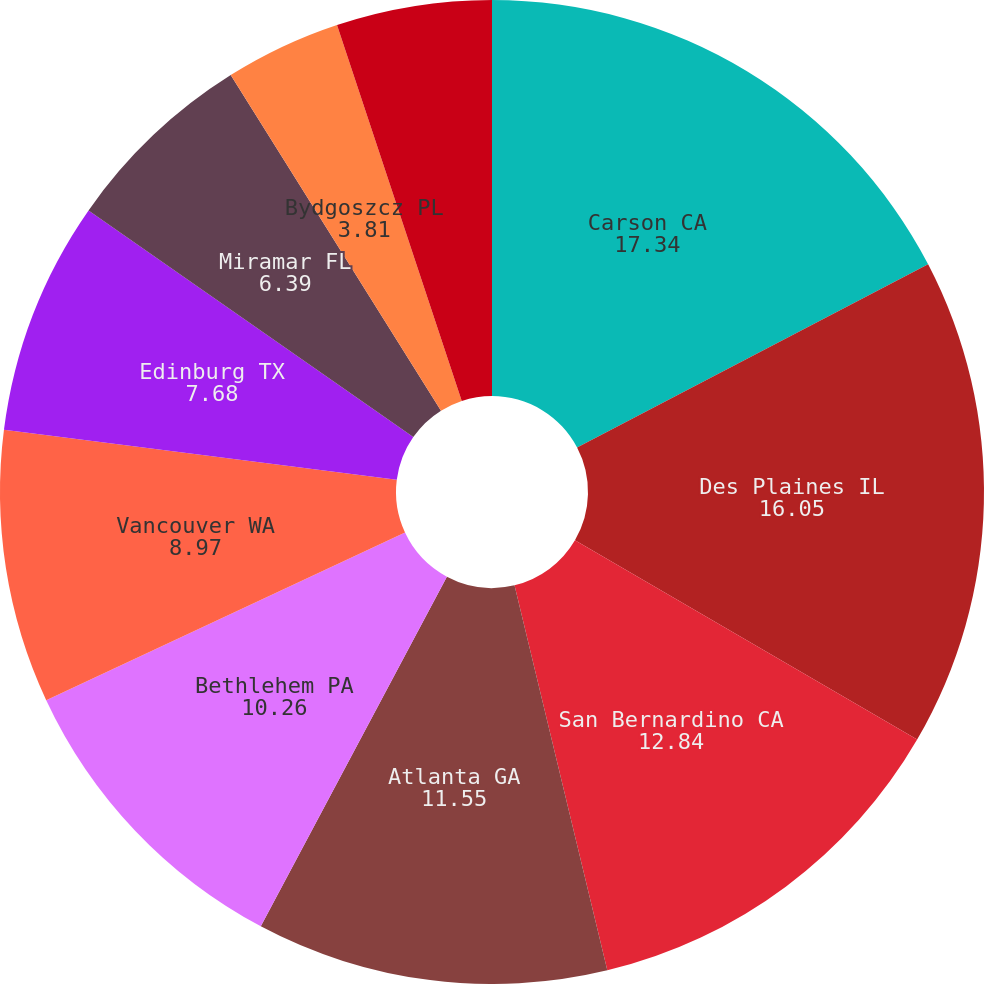<chart> <loc_0><loc_0><loc_500><loc_500><pie_chart><fcel>Carson CA<fcel>Des Plaines IL<fcel>San Bernardino CA<fcel>Atlanta GA<fcel>Bethlehem PA<fcel>Vancouver WA<fcel>Edinburg TX<fcel>Miramar FL<fcel>Bydgoszcz PL<fcel>Cobden IL (1)<nl><fcel>17.34%<fcel>16.05%<fcel>12.84%<fcel>11.55%<fcel>10.26%<fcel>8.97%<fcel>7.68%<fcel>6.39%<fcel>3.81%<fcel>5.1%<nl></chart> 